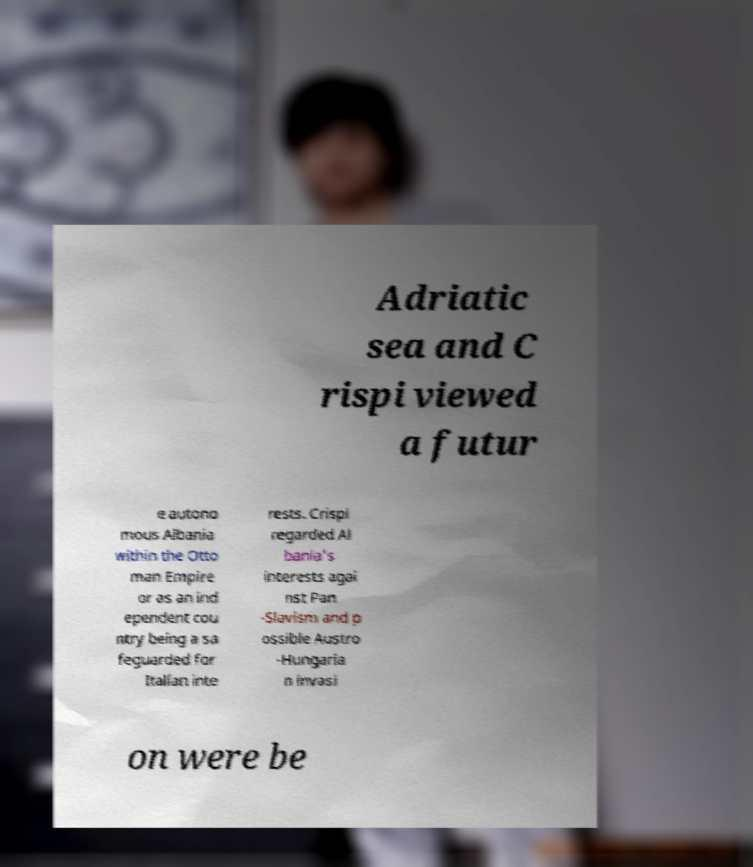I need the written content from this picture converted into text. Can you do that? Adriatic sea and C rispi viewed a futur e autono mous Albania within the Otto man Empire or as an ind ependent cou ntry being a sa feguarded for Italian inte rests. Crispi regarded Al bania's interests agai nst Pan -Slavism and p ossible Austro -Hungaria n invasi on were be 